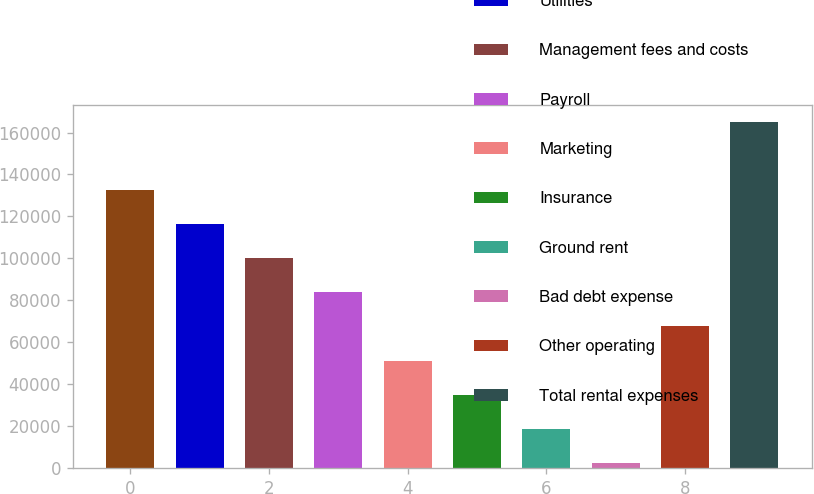Convert chart. <chart><loc_0><loc_0><loc_500><loc_500><bar_chart><fcel>Repairs and maintenance<fcel>Utilities<fcel>Management fees and costs<fcel>Payroll<fcel>Marketing<fcel>Insurance<fcel>Ground rent<fcel>Bad debt expense<fcel>Other operating<fcel>Total rental expenses<nl><fcel>132430<fcel>116200<fcel>99970.4<fcel>83740.5<fcel>51280.7<fcel>35050.8<fcel>18820.9<fcel>2591<fcel>67510.6<fcel>164890<nl></chart> 